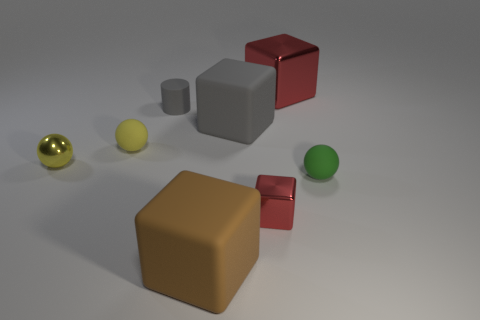Subtract all yellow spheres. How many were subtracted if there are1yellow spheres left? 1 Subtract 1 blocks. How many blocks are left? 3 Subtract all cyan balls. Subtract all cyan cylinders. How many balls are left? 3 Add 2 gray spheres. How many objects exist? 10 Subtract all spheres. How many objects are left? 5 Add 5 yellow shiny objects. How many yellow shiny objects are left? 6 Add 4 tiny yellow metallic cylinders. How many tiny yellow metallic cylinders exist? 4 Subtract 0 red spheres. How many objects are left? 8 Subtract all green shiny spheres. Subtract all tiny gray matte objects. How many objects are left? 7 